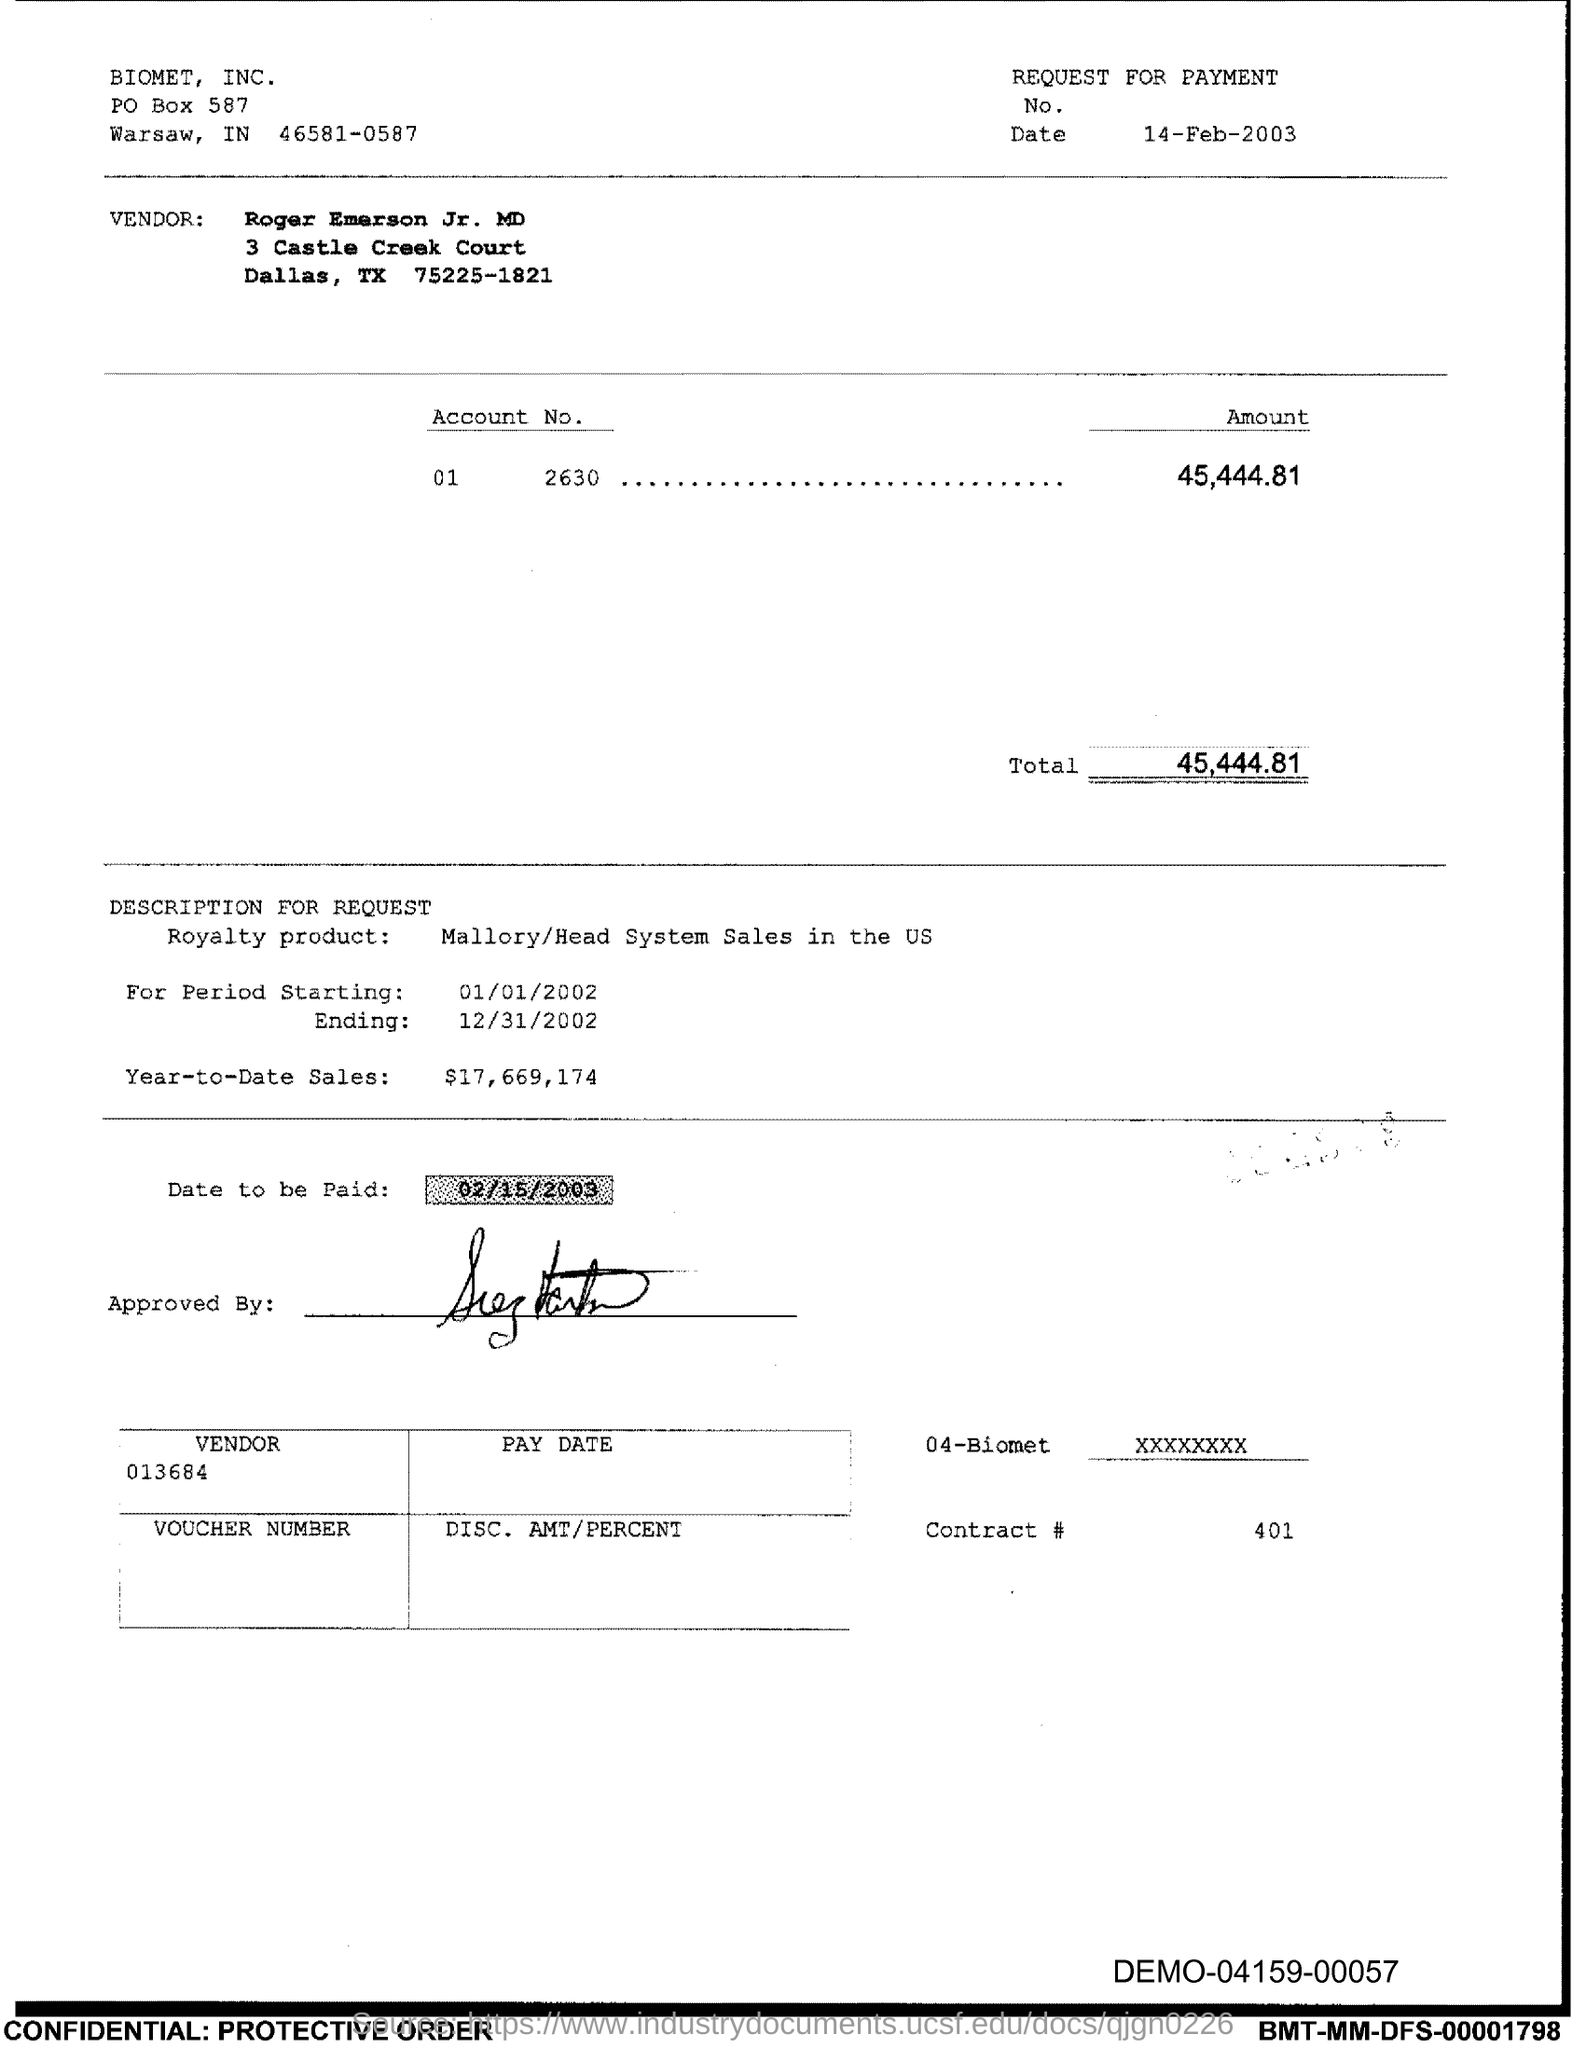Who is the vendor listed on this payment request? The vendor listed on the payment request is Roger Emerson Jr. MD, with the address provided as 3 Castle Creek Court, Dallas, TX 75225-1821. Is there any product mentioned in relation to this payment request? Yes, according to the document, the payment request pertains to 'Royalty product: Mallory/Head System Sales in the US' for the period starting January 1, 2002, and ending December 31, 2002. 